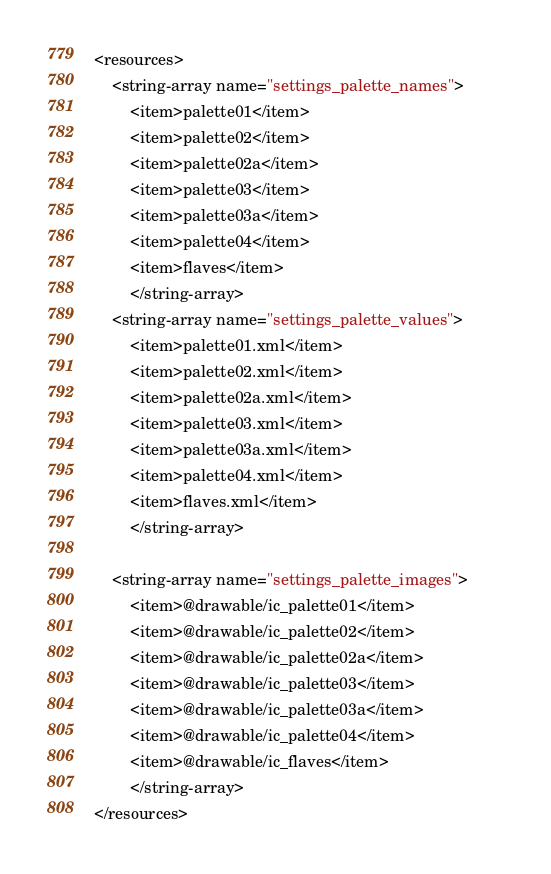Convert code to text. <code><loc_0><loc_0><loc_500><loc_500><_XML_><resources>
    <string-array name="settings_palette_names">        
        <item>palette01</item>
        <item>palette02</item>
        <item>palette02a</item>
        <item>palette03</item>
        <item>palette03a</item>
        <item>palette04</item>
        <item>flaves</item>
        </string-array>
    <string-array name="settings_palette_values">        
        <item>palette01.xml</item>
        <item>palette02.xml</item>
        <item>palette02a.xml</item>
        <item>palette03.xml</item>
        <item>palette03a.xml</item>
        <item>palette04.xml</item>
        <item>flaves.xml</item>
        </string-array>

    <string-array name="settings_palette_images">        
        <item>@drawable/ic_palette01</item>
        <item>@drawable/ic_palette02</item>
        <item>@drawable/ic_palette02a</item>
        <item>@drawable/ic_palette03</item>
        <item>@drawable/ic_palette03a</item>
        <item>@drawable/ic_palette04</item>
        <item>@drawable/ic_flaves</item>
        </string-array>
</resources></code> 